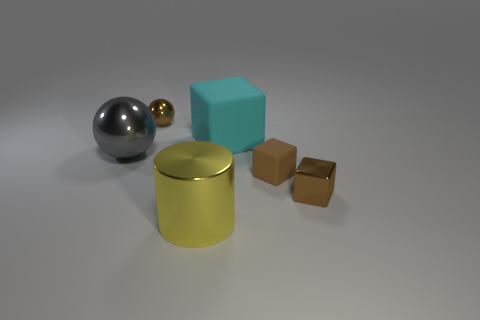Add 2 gray matte blocks. How many objects exist? 8 Subtract all cylinders. How many objects are left? 5 Add 1 tiny brown cubes. How many tiny brown cubes are left? 3 Add 5 small shiny spheres. How many small shiny spheres exist? 6 Subtract 0 cyan cylinders. How many objects are left? 6 Subtract all yellow things. Subtract all brown objects. How many objects are left? 2 